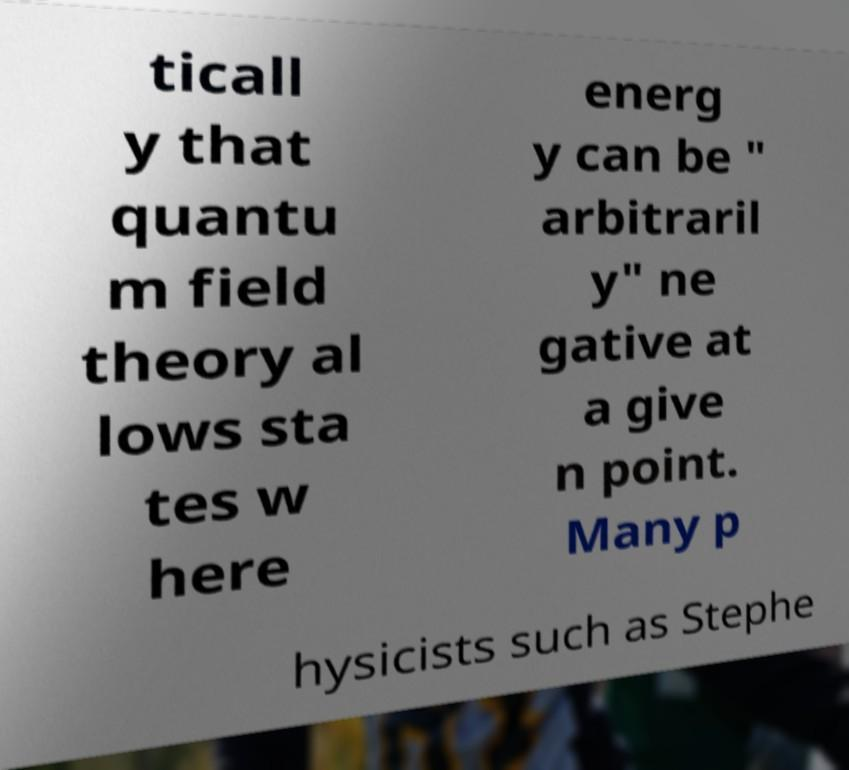Please read and relay the text visible in this image. What does it say? ticall y that quantu m field theory al lows sta tes w here energ y can be " arbitraril y" ne gative at a give n point. Many p hysicists such as Stephe 